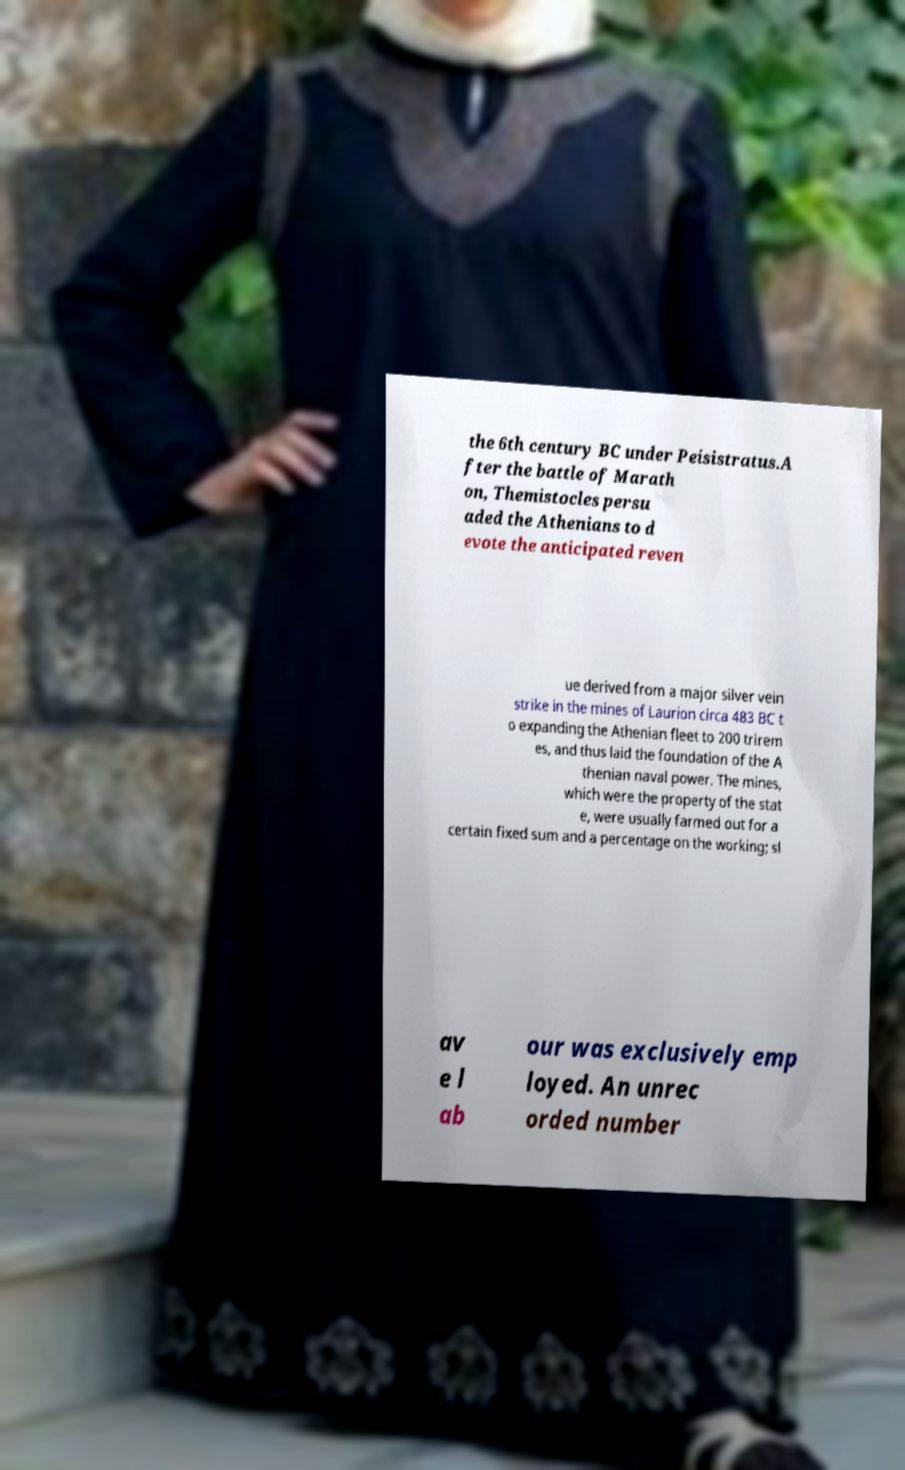Please read and relay the text visible in this image. What does it say? the 6th century BC under Peisistratus.A fter the battle of Marath on, Themistocles persu aded the Athenians to d evote the anticipated reven ue derived from a major silver vein strike in the mines of Laurion circa 483 BC t o expanding the Athenian fleet to 200 trirem es, and thus laid the foundation of the A thenian naval power. The mines, which were the property of the stat e, were usually farmed out for a certain fixed sum and a percentage on the working; sl av e l ab our was exclusively emp loyed. An unrec orded number 